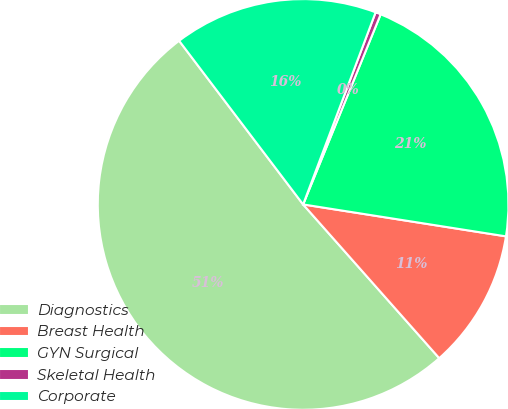Convert chart to OTSL. <chart><loc_0><loc_0><loc_500><loc_500><pie_chart><fcel>Diagnostics<fcel>Breast Health<fcel>GYN Surgical<fcel>Skeletal Health<fcel>Corporate<nl><fcel>51.21%<fcel>10.98%<fcel>21.32%<fcel>0.42%<fcel>16.06%<nl></chart> 